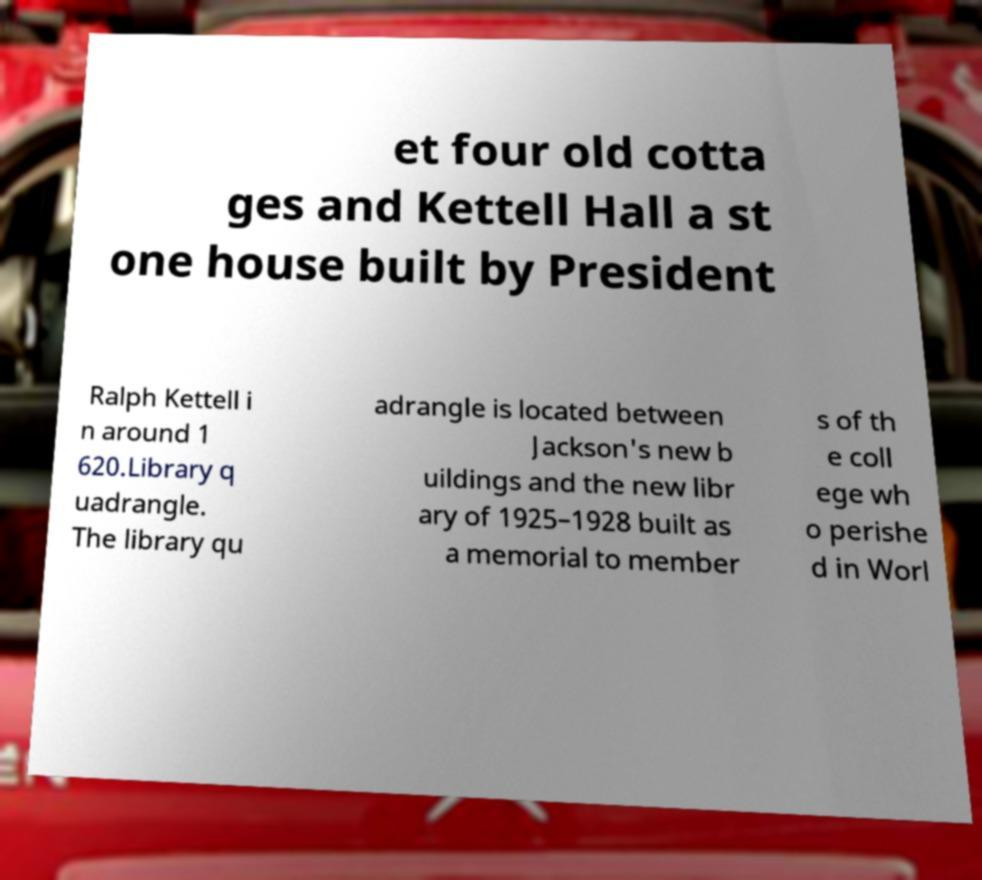Can you read and provide the text displayed in the image?This photo seems to have some interesting text. Can you extract and type it out for me? et four old cotta ges and Kettell Hall a st one house built by President Ralph Kettell i n around 1 620.Library q uadrangle. The library qu adrangle is located between Jackson's new b uildings and the new libr ary of 1925–1928 built as a memorial to member s of th e coll ege wh o perishe d in Worl 